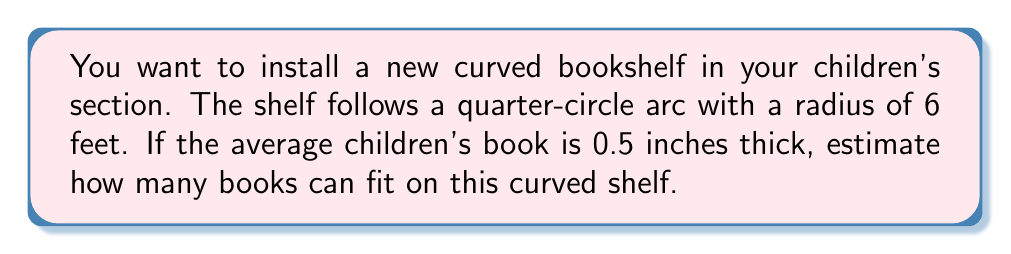Could you help me with this problem? Let's approach this step-by-step:

1. First, we need to calculate the length of the shelf. The shelf forms a quarter-circle, so its length is a quarter of the circumference of a full circle.

   Circumference of a full circle: $C = 2\pi r$
   Length of our shelf: $L = \frac{1}{4} \cdot 2\pi r = \frac{\pi r}{2}$

2. Substitute the radius (6 feet):
   $L = \frac{\pi \cdot 6}{2} = 3\pi$ feet

3. Convert the length to inches:
   $L_{inches} = 3\pi \cdot 12 = 36\pi$ inches

4. Now, if each book is 0.5 inches thick, we can estimate the number of books by dividing the shelf length by the book thickness:

   Number of books $= \frac{36\pi}{0.5} = 72\pi$

5. $72\pi \approx 226.19$

6. Since we can't have a fractional book, we round down to the nearest whole number.

[asy]
unitsize(30);
draw(arc((0,0),2,0,90));
draw((0,0)--(2,0));
draw((0,0)--(0,2));
label("6 ft", (1,0), S);
label("6 ft", (0,1), W);
label("Curved Shelf", (1.4,1.4), NE);
[/asy]
Answer: 226 books 